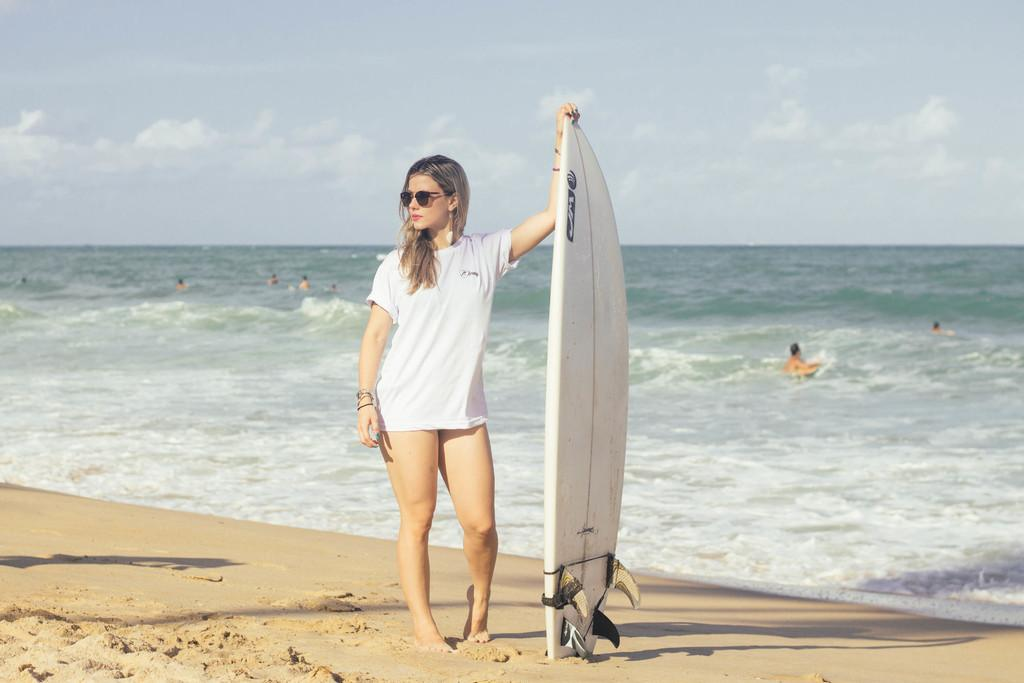Who is present in the image? There is a woman in the image. Where is the woman located? The woman is standing near the beach. What is the woman holding in the image? The woman is holding a surfing board. What is the condition of the sky in the background of the image? The sky is cloudy in the background of the image. What type of floor can be seen in the image? There is no floor visible in the image, as it is set near the beach. 